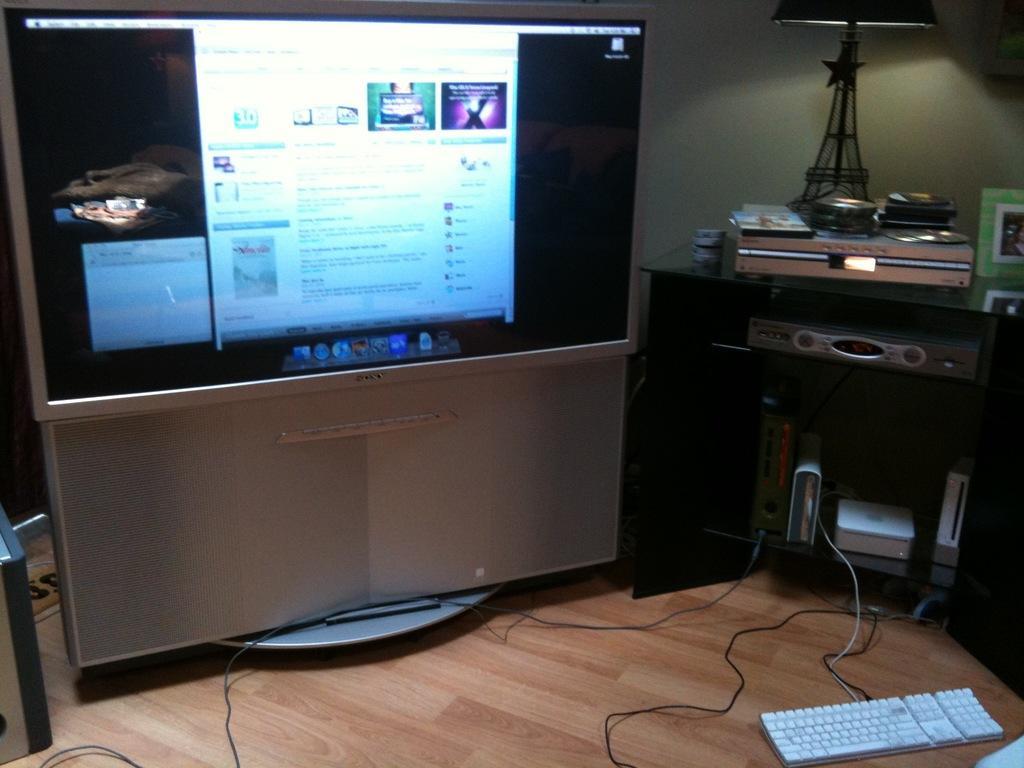In one or two sentences, can you explain what this image depicts? In this image we can see a monitor on the left side, on the right we can see electronic objects, we can see a table and lamp. And we can see keyboard on the floor. 